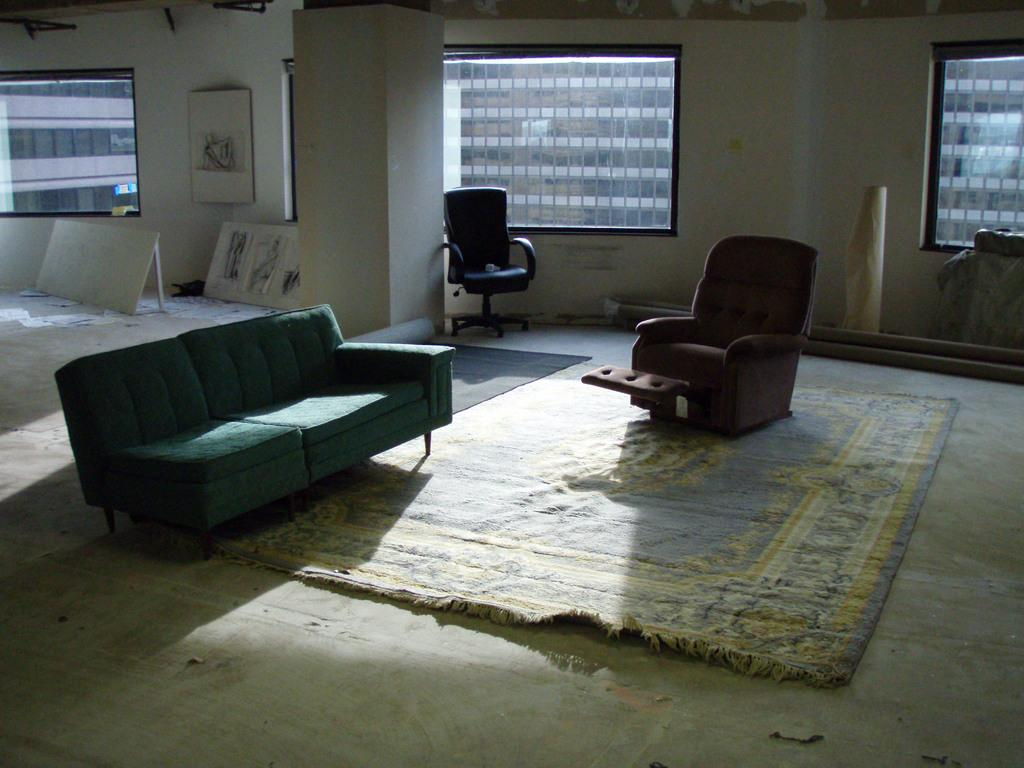What type of furniture is present in the image? There is a couch and a chair in the image. What is on the floor in the image? There is a carpet on the floor in the image. What can be seen in the background of the image? There are windows in the background of the image. What type of vegetable is being used as a decoration on the couch in the image? There is no vegetable present on the couch in the image. How many people are sleeping on the chair in the image? There are no people sleeping in the image; it only shows a couch, a chair, and a carpet on the floor. 